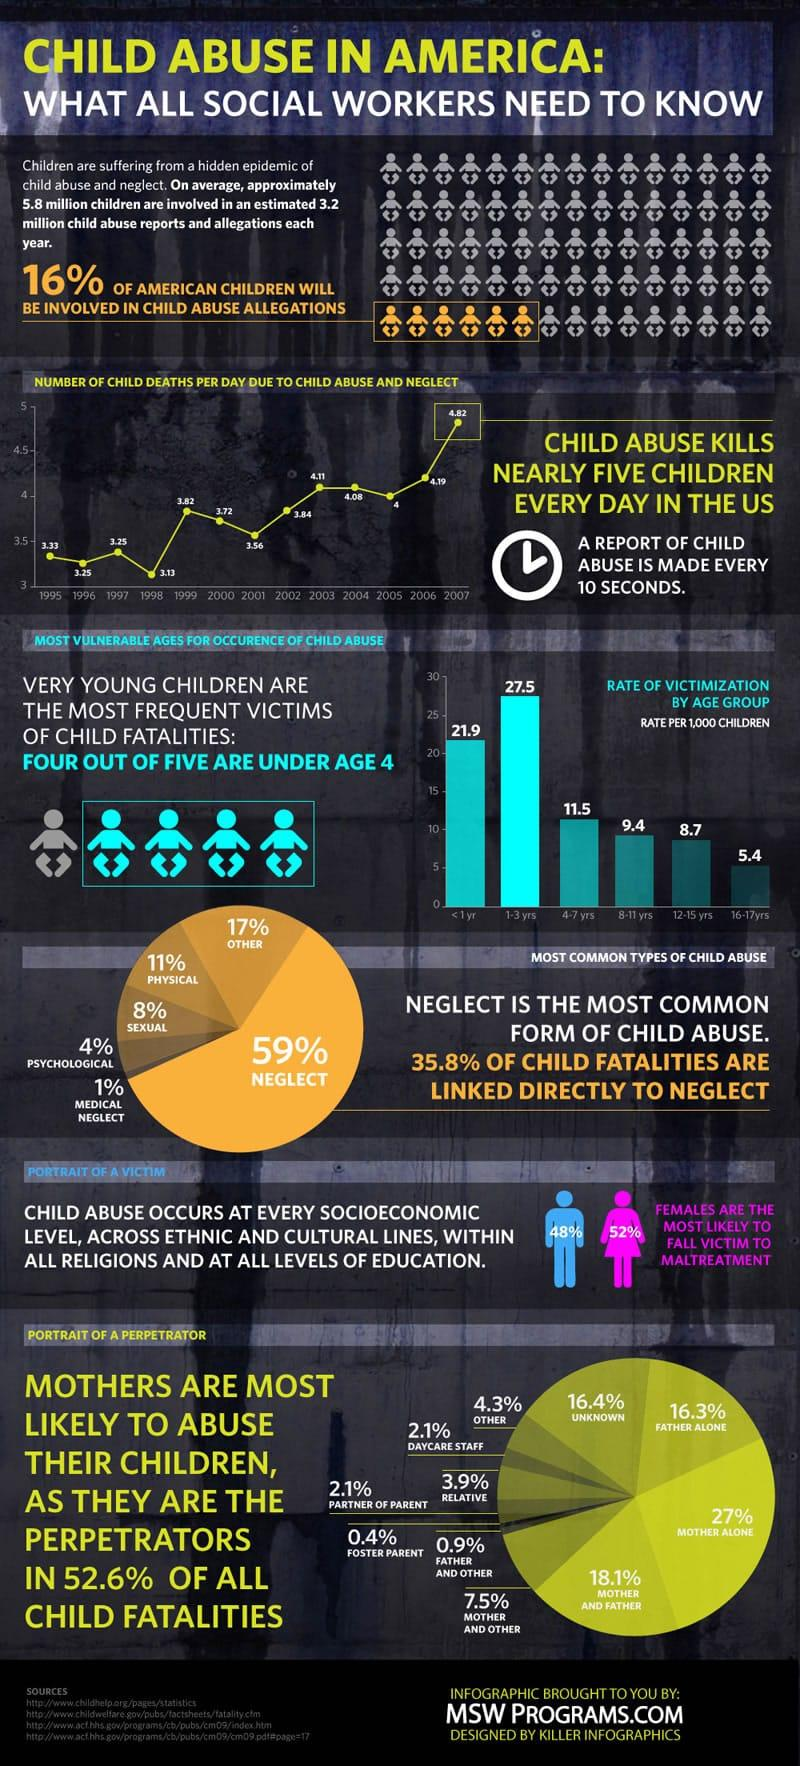Indicate a few pertinent items in this graphic. According to data, the year 2007 had the highest number of child deaths due to child abuse and neglect. It is estimated that 27.5 children out of every 1,000 in the age group of 1-3 years are victimized. A recent study found that only 6.0% of abuse is carried out by daycare staff and relatives. 